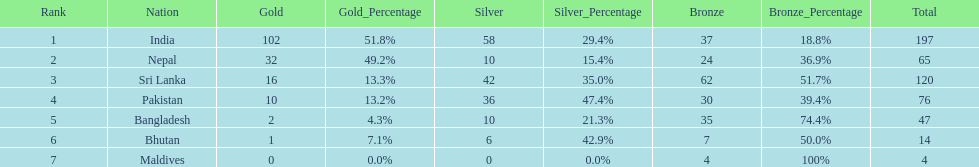What are the total number of bronze medals sri lanka have earned? 62. 